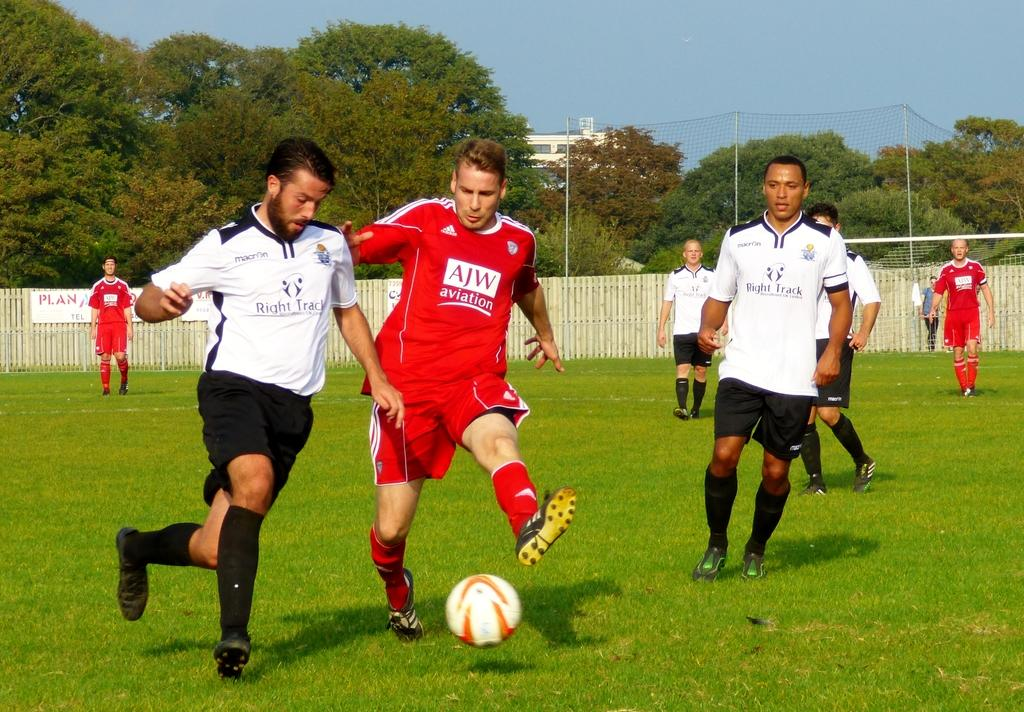What activity is the group of people engaged in? The group of people is playing football. Where is the football game taking place? The football game is taking place on a grass field. What is the condition of the grass field? The grass field is surrounded by fencing. What can be seen near the grass field? Trees and houses are visible near the grass field. What is the color of the sky in the image? The sky is blue. What type of canvas is being used for the addition of impulse in the image? There is no canvas, addition, or impulse present in the image; it features a group of people playing football on a grass field. 